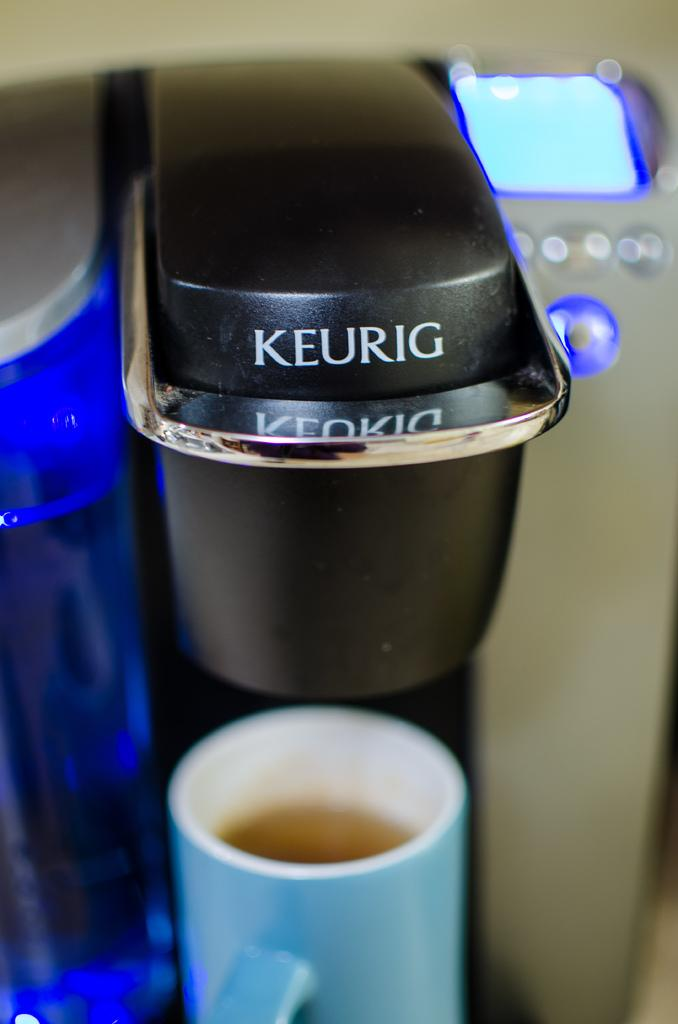What appliance can be seen in the image? There is a coffee machine in the image. What color is the coffee cup at the bottom of the image? The coffee cup is blue. Where is the electronic display located in the image? The electronic display is in blue color on the right side of the image. What scent is emitted from the coffee machine in the image? The image does not provide information about the scent emitted from the coffee machine. How does the tongue interact with the coffee cup in the image? There is no tongue present in the image, as it is a still image and not a video. 